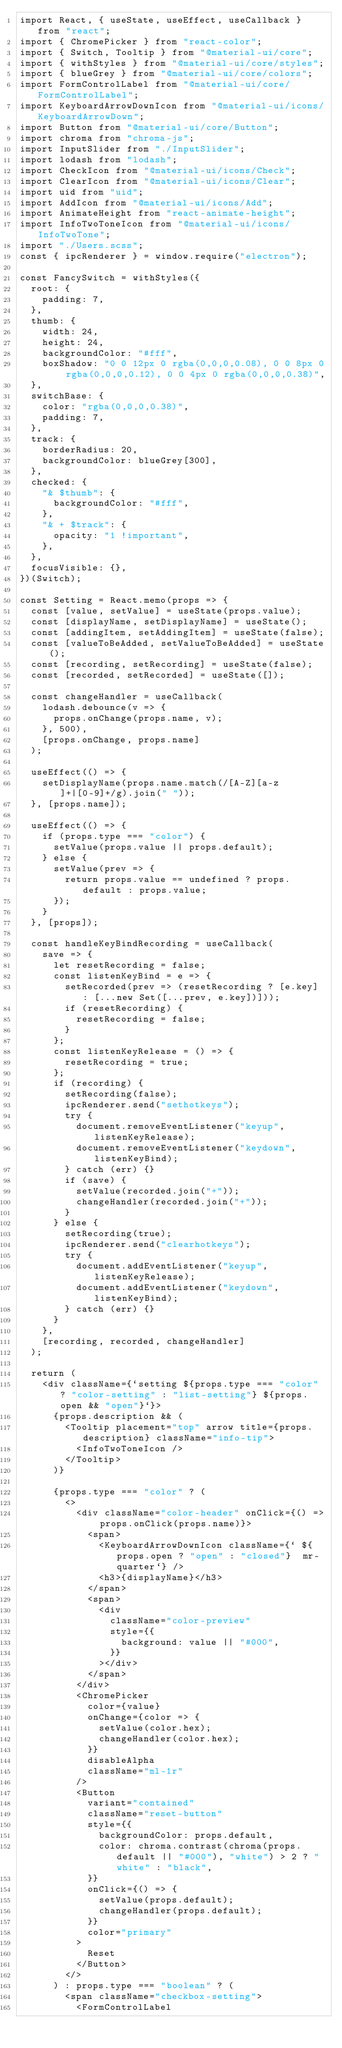Convert code to text. <code><loc_0><loc_0><loc_500><loc_500><_JavaScript_>import React, { useState, useEffect, useCallback } from "react";
import { ChromePicker } from "react-color";
import { Switch, Tooltip } from "@material-ui/core";
import { withStyles } from "@material-ui/core/styles";
import { blueGrey } from "@material-ui/core/colors";
import FormControlLabel from "@material-ui/core/FormControlLabel";
import KeyboardArrowDownIcon from "@material-ui/icons/KeyboardArrowDown";
import Button from "@material-ui/core/Button";
import chroma from "chroma-js";
import InputSlider from "./InputSlider";
import lodash from "lodash";
import CheckIcon from "@material-ui/icons/Check";
import ClearIcon from "@material-ui/icons/Clear";
import uid from "uid";
import AddIcon from "@material-ui/icons/Add";
import AnimateHeight from "react-animate-height";
import InfoTwoToneIcon from "@material-ui/icons/InfoTwoTone";
import "./Users.scss";
const { ipcRenderer } = window.require("electron");

const FancySwitch = withStyles({
	root: {
		padding: 7,
	},
	thumb: {
		width: 24,
		height: 24,
		backgroundColor: "#fff",
		boxShadow: "0 0 12px 0 rgba(0,0,0,0.08), 0 0 8px 0 rgba(0,0,0,0.12), 0 0 4px 0 rgba(0,0,0,0.38)",
	},
	switchBase: {
		color: "rgba(0,0,0,0.38)",
		padding: 7,
	},
	track: {
		borderRadius: 20,
		backgroundColor: blueGrey[300],
	},
	checked: {
		"& $thumb": {
			backgroundColor: "#fff",
		},
		"& + $track": {
			opacity: "1 !important",
		},
	},
	focusVisible: {},
})(Switch);

const Setting = React.memo(props => {
	const [value, setValue] = useState(props.value);
	const [displayName, setDisplayName] = useState();
	const [addingItem, setAddingItem] = useState(false);
	const [valueToBeAdded, setValueToBeAdded] = useState();
	const [recording, setRecording] = useState(false);
	const [recorded, setRecorded] = useState([]);

	const changeHandler = useCallback(
		lodash.debounce(v => {
			props.onChange(props.name, v);
		}, 500),
		[props.onChange, props.name]
	);

	useEffect(() => {
		setDisplayName(props.name.match(/[A-Z][a-z]+|[0-9]+/g).join(" "));
	}, [props.name]);

	useEffect(() => {
		if (props.type === "color") {
			setValue(props.value || props.default);
		} else {
			setValue(prev => {
				return props.value == undefined ? props.default : props.value;
			});
		}
	}, [props]);

	const handleKeyBindRecording = useCallback(
		save => {
			let resetRecording = false;
			const listenKeyBind = e => {
				setRecorded(prev => (resetRecording ? [e.key] : [...new Set([...prev, e.key])]));
				if (resetRecording) {
					resetRecording = false;
				}
			};
			const listenKeyRelease = () => {
				resetRecording = true;
			};
			if (recording) {
				setRecording(false);
				ipcRenderer.send("sethotkeys");
				try {
					document.removeEventListener("keyup", listenKeyRelease);
					document.removeEventListener("keydown", listenKeyBind);
				} catch (err) {}
				if (save) {
					setValue(recorded.join("+"));
					changeHandler(recorded.join("+"));
				}
			} else {
				setRecording(true);
				ipcRenderer.send("clearhotkeys");
				try {
					document.addEventListener("keyup", listenKeyRelease);
					document.addEventListener("keydown", listenKeyBind);
				} catch (err) {}
			}
		},
		[recording, recorded, changeHandler]
	);

	return (
		<div className={`setting ${props.type === "color" ? "color-setting" : "list-setting"} ${props.open && "open"}`}>
			{props.description && (
				<Tooltip placement="top" arrow title={props.description} className="info-tip">
					<InfoTwoToneIcon />
				</Tooltip>
			)}

			{props.type === "color" ? (
				<>
					<div className="color-header" onClick={() => props.onClick(props.name)}>
						<span>
							<KeyboardArrowDownIcon className={` ${props.open ? "open" : "closed"}  mr-quarter`} />
							<h3>{displayName}</h3>
						</span>
						<span>
							<div
								className="color-preview"
								style={{
									background: value || "#000",
								}}
							></div>
						</span>
					</div>
					<ChromePicker
						color={value}
						onChange={color => {
							setValue(color.hex);
							changeHandler(color.hex);
						}}
						disableAlpha
						className="ml-1r"
					/>
					<Button
						variant="contained"
						className="reset-button"
						style={{
							backgroundColor: props.default,
							color: chroma.contrast(chroma(props.default || "#000"), "white") > 2 ? "white" : "black",
						}}
						onClick={() => {
							setValue(props.default);
							changeHandler(props.default);
						}}
						color="primary"
					>
						Reset
					</Button>
				</>
			) : props.type === "boolean" ? (
				<span className="checkbox-setting">
					<FormControlLabel</code> 